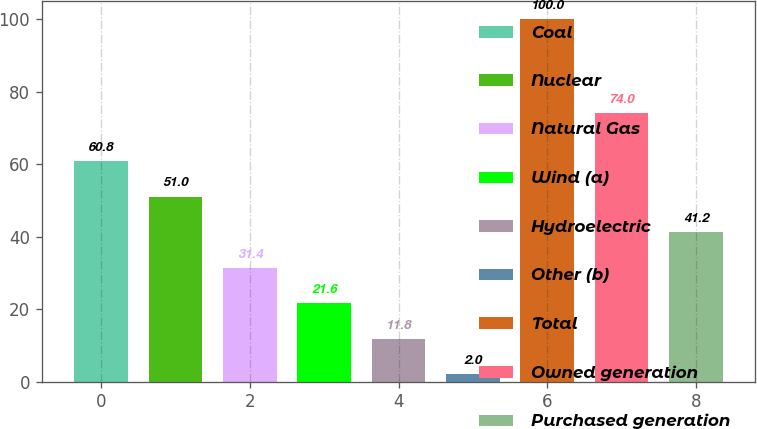Convert chart to OTSL. <chart><loc_0><loc_0><loc_500><loc_500><bar_chart><fcel>Coal<fcel>Nuclear<fcel>Natural Gas<fcel>Wind (a)<fcel>Hydroelectric<fcel>Other (b)<fcel>Total<fcel>Owned generation<fcel>Purchased generation<nl><fcel>60.8<fcel>51<fcel>31.4<fcel>21.6<fcel>11.8<fcel>2<fcel>100<fcel>74<fcel>41.2<nl></chart> 